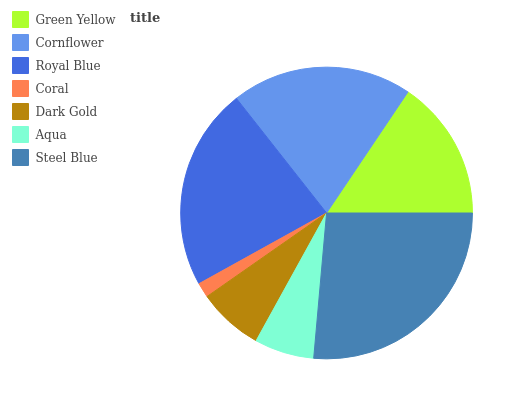Is Coral the minimum?
Answer yes or no. Yes. Is Steel Blue the maximum?
Answer yes or no. Yes. Is Cornflower the minimum?
Answer yes or no. No. Is Cornflower the maximum?
Answer yes or no. No. Is Cornflower greater than Green Yellow?
Answer yes or no. Yes. Is Green Yellow less than Cornflower?
Answer yes or no. Yes. Is Green Yellow greater than Cornflower?
Answer yes or no. No. Is Cornflower less than Green Yellow?
Answer yes or no. No. Is Green Yellow the high median?
Answer yes or no. Yes. Is Green Yellow the low median?
Answer yes or no. Yes. Is Coral the high median?
Answer yes or no. No. Is Steel Blue the low median?
Answer yes or no. No. 